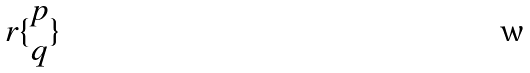Convert formula to latex. <formula><loc_0><loc_0><loc_500><loc_500>r \{ \begin{matrix} p \\ q \end{matrix} \}</formula> 